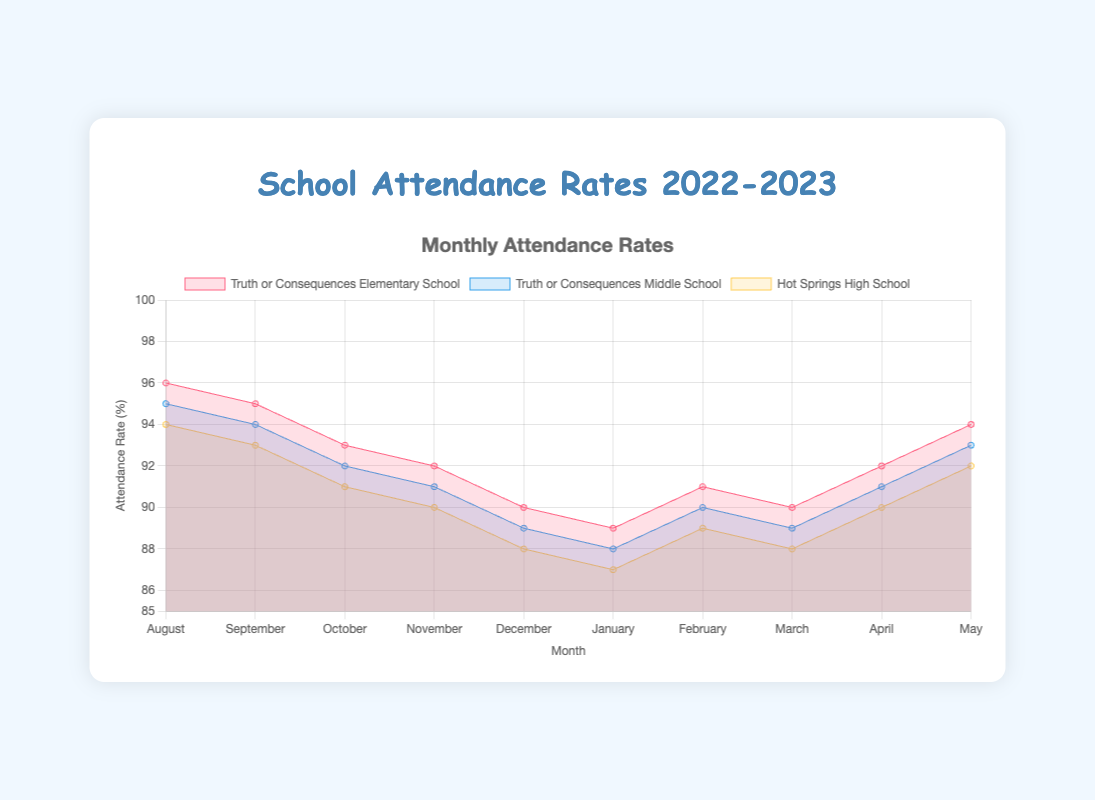How many months of data are displayed for Truth or Consequences Elementary School? The x-axis of the chart shows the months from August to May, totaling 10 months.
Answer: 10 What is the attendance rate for Truth or Consequences Middle School in December? The line for Truth or Consequences Middle School (depicted in blue) intersects the y-axis at 89% in December.
Answer: 89% Which month had the highest attendance rate for Hot Springs High School? By scanning the yellow line for Hot Springs High School, August had the highest attendance rate at 94%.
Answer: August How does the attendance rate of Truth or Consequences Elementary School in January compare to February? In January, the attendance rate is 89%, and in February, it increases to 91%.
Answer: January: 89%, February: 91% What is the average attendance rate for Truth or Consequences Elementary School over the first quarter (August to October)? The rates for August, September, and October are 96%, 95%, and 93% respectively. The average is (96 + 95 + 93) / 3 = 94.67%.
Answer: 94.67% Which school had the steepest decline in attendance rates between August and January? Truth or Consequences Middle School fell from 95% to 88%, a drop of 7%. This is more significant compared to the other schools' declines in the same period.
Answer: Truth or Consequences Middle School In which month did all three schools record the lowest attendance rates? By examining the lines, each school hits their lowest point in January: Truth or Consequences Elementary at 89%, Middle School at 88%, and High School at 87%.
Answer: January What is the overall trend in attendance rates for the Truth or Consequences Elementary School from August to May? The trend generally shows a decline from August (96%) to January (89%), followed by a slight recovery in the later months, peaking again in May at 94%.
Answer: Decline, slight recovery Compare the attendance trends for Truth or Consequences Middle School and Hot Springs High School in the second semester (January to May). Both schools show an increase in attendance rates from January to May. The Middle School increases from 88% to 93%, while the High School increases from 87% to 92%.
Answer: Both increased 